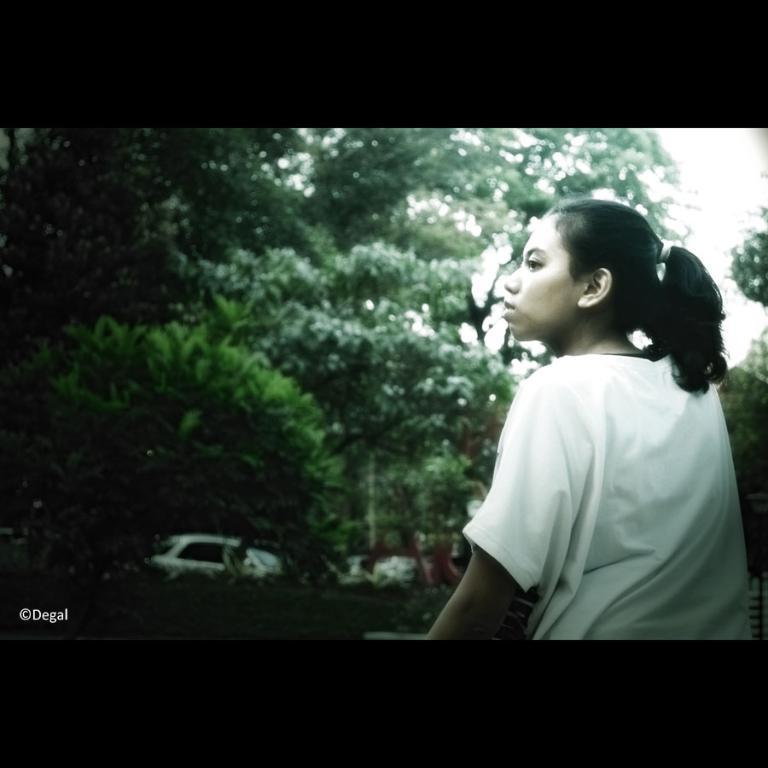Who or what is the main subject in the image? There is a person in the image. What is located behind the person? There is a group of trees behind the person. What type of vehicle can be seen in the image? There is a car visible in the image. What part of the natural environment is visible in the image? The sky is visible in the image. What is present in the bottom left corner of the image? There is some text in the bottom left corner of the image. Reasoning: Let'g: Let's think step by step in order to produce the conversation. We start by identifying the main subject in the image, which is the person. Then, we expand the conversation to include other elements in the image, such as the trees, car, sky, and text. Each question is designed to elicit a specific detail about the image that is known from the provided facts. Absurd Question/Answer: How does the person measure the existence of the frame in the image? There is no frame present in the image, so the person cannot measure its existence. 